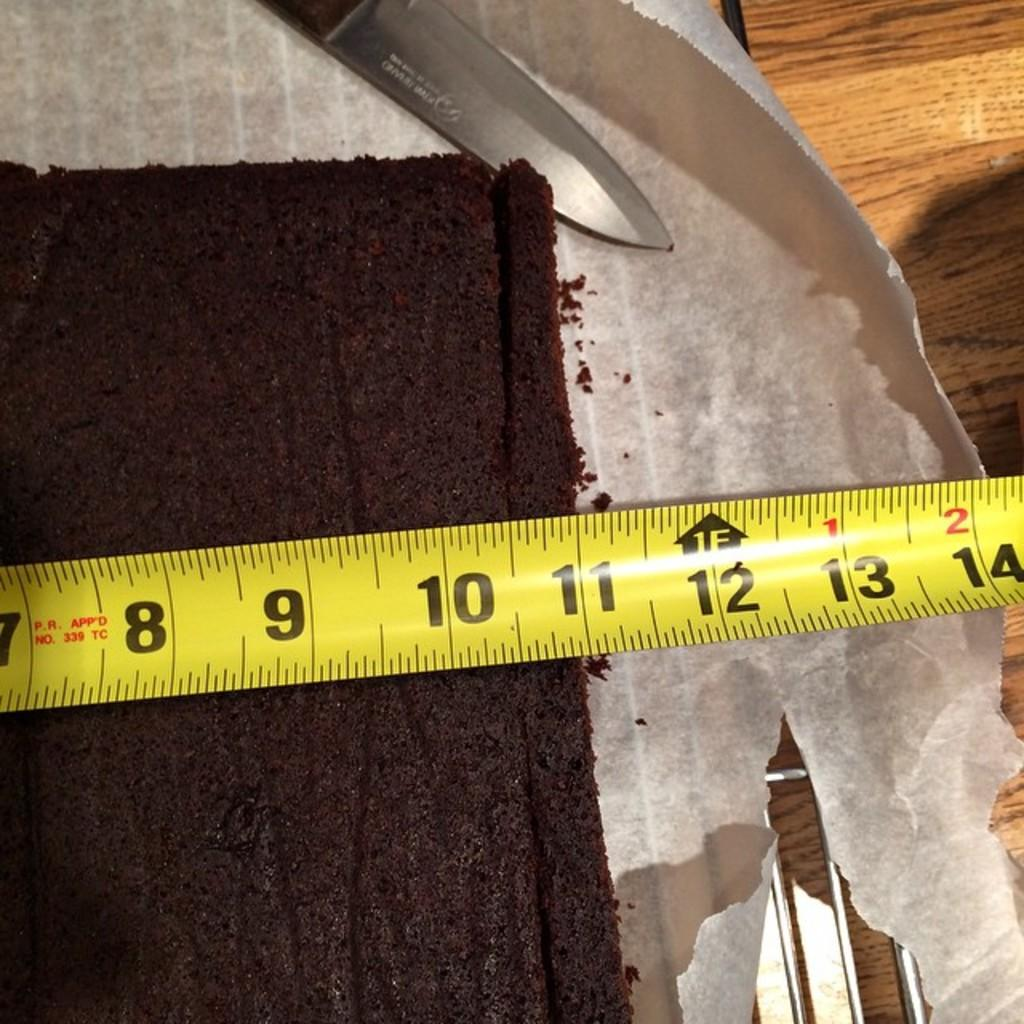<image>
Describe the image concisely. a ruler with 7 through 14 in. displayed 